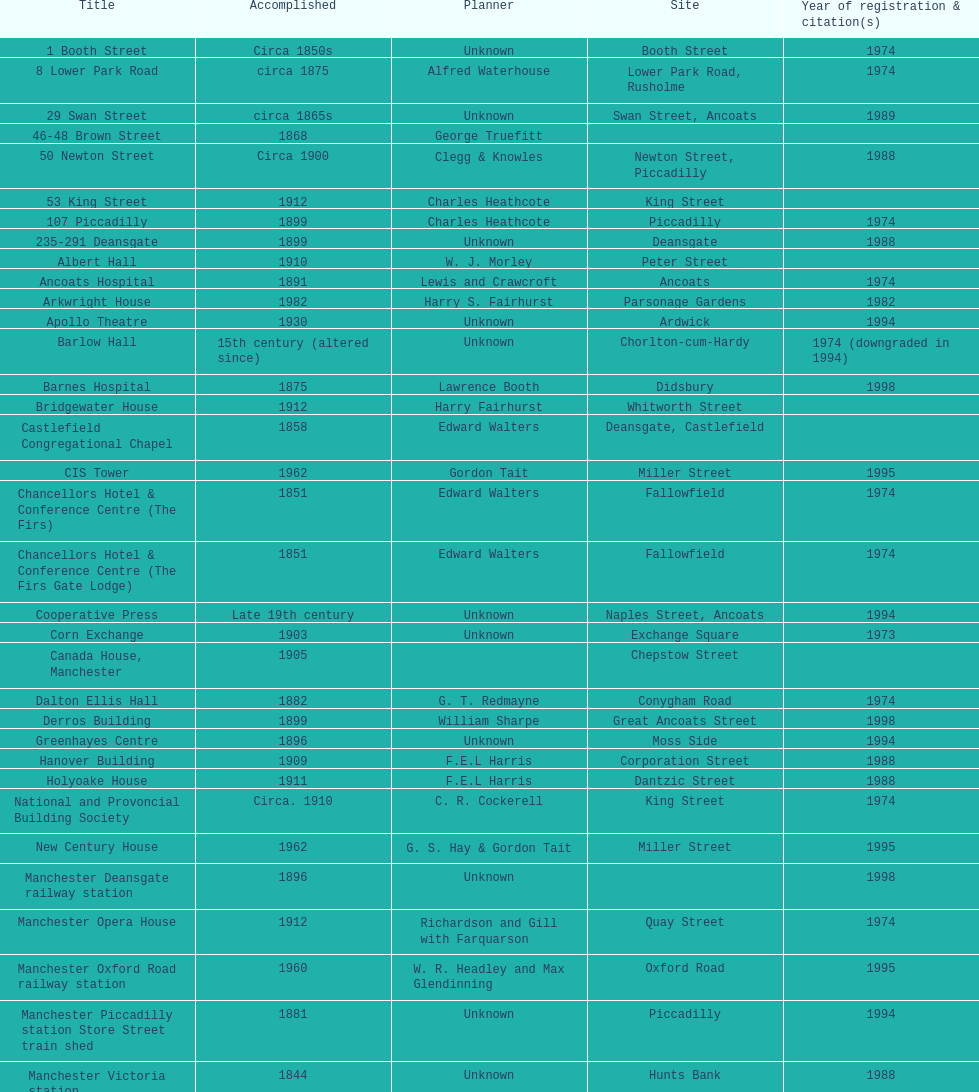Write the full table. {'header': ['Title', 'Accomplished', 'Planner', 'Site', 'Year of registration & citation(s)'], 'rows': [['1 Booth Street', 'Circa 1850s', 'Unknown', 'Booth Street', '1974'], ['8 Lower Park Road', 'circa 1875', 'Alfred Waterhouse', 'Lower Park Road, Rusholme', '1974'], ['29 Swan Street', 'circa 1865s', 'Unknown', 'Swan Street, Ancoats', '1989'], ['46-48 Brown Street', '1868', 'George Truefitt', '', ''], ['50 Newton Street', 'Circa 1900', 'Clegg & Knowles', 'Newton Street, Piccadilly', '1988'], ['53 King Street', '1912', 'Charles Heathcote', 'King Street', ''], ['107 Piccadilly', '1899', 'Charles Heathcote', 'Piccadilly', '1974'], ['235-291 Deansgate', '1899', 'Unknown', 'Deansgate', '1988'], ['Albert Hall', '1910', 'W. J. Morley', 'Peter Street', ''], ['Ancoats Hospital', '1891', 'Lewis and Crawcroft', 'Ancoats', '1974'], ['Arkwright House', '1982', 'Harry S. Fairhurst', 'Parsonage Gardens', '1982'], ['Apollo Theatre', '1930', 'Unknown', 'Ardwick', '1994'], ['Barlow Hall', '15th century (altered since)', 'Unknown', 'Chorlton-cum-Hardy', '1974 (downgraded in 1994)'], ['Barnes Hospital', '1875', 'Lawrence Booth', 'Didsbury', '1998'], ['Bridgewater House', '1912', 'Harry Fairhurst', 'Whitworth Street', ''], ['Castlefield Congregational Chapel', '1858', 'Edward Walters', 'Deansgate, Castlefield', ''], ['CIS Tower', '1962', 'Gordon Tait', 'Miller Street', '1995'], ['Chancellors Hotel & Conference Centre (The Firs)', '1851', 'Edward Walters', 'Fallowfield', '1974'], ['Chancellors Hotel & Conference Centre (The Firs Gate Lodge)', '1851', 'Edward Walters', 'Fallowfield', '1974'], ['Cooperative Press', 'Late 19th century', 'Unknown', 'Naples Street, Ancoats', '1994'], ['Corn Exchange', '1903', 'Unknown', 'Exchange Square', '1973'], ['Canada House, Manchester', '1905', '', 'Chepstow Street', ''], ['Dalton Ellis Hall', '1882', 'G. T. Redmayne', 'Conygham Road', '1974'], ['Derros Building', '1899', 'William Sharpe', 'Great Ancoats Street', '1998'], ['Greenhayes Centre', '1896', 'Unknown', 'Moss Side', '1994'], ['Hanover Building', '1909', 'F.E.L Harris', 'Corporation Street', '1988'], ['Holyoake House', '1911', 'F.E.L Harris', 'Dantzic Street', '1988'], ['National and Provoncial Building Society', 'Circa. 1910', 'C. R. Cockerell', 'King Street', '1974'], ['New Century House', '1962', 'G. S. Hay & Gordon Tait', 'Miller Street', '1995'], ['Manchester Deansgate railway station', '1896', 'Unknown', '', '1998'], ['Manchester Opera House', '1912', 'Richardson and Gill with Farquarson', 'Quay Street', '1974'], ['Manchester Oxford Road railway station', '1960', 'W. R. Headley and Max Glendinning', 'Oxford Road', '1995'], ['Manchester Piccadilly station Store Street train shed', '1881', 'Unknown', 'Piccadilly', '1994'], ['Manchester Victoria station', '1844', 'Unknown', 'Hunts Bank', '1988'], ['Palace Theatre', '1891', 'Alfred Derbyshire and F.Bennett Smith', 'Oxford Street', '1977'], ['The Ritz', '1927', 'Unknown', 'Whitworth Street', '1994'], ['Royal Exchange', '1921', 'Bradshaw, Gass & Hope', 'Cross Street', ''], ['Redfern Building', '1936', 'W. A. Johnson and J. W. Cooper', 'Dantzic Street', '1994'], ['Sackville Street Building', '1912', 'Spalding and Cross', 'Sackville Street', '1974'], ['St. James Buildings', '1912', 'Clegg, Fryer & Penman', '65-95 Oxford Street', '1988'], ["St Mary's Hospital", '1909', 'John Ely', 'Wilmslow Road', '1994'], ['Samuel Alexander Building', '1919', 'Percy Scott Worthington', 'Oxford Road', '2010'], ['Ship Canal House', '1927', 'Harry S. Fairhurst', 'King Street', '1982'], ['Smithfield Market Hall', '1857', 'Unknown', 'Swan Street, Ancoats', '1973'], ['Strangeways Gaol Gatehouse', '1868', 'Alfred Waterhouse', 'Sherborne Street', '1974'], ['Strangeways Prison ventilation and watch tower', '1868', 'Alfred Waterhouse', 'Sherborne Street', '1974'], ['Theatre Royal', '1845', 'Irwin and Chester', 'Peter Street', '1974'], ['Toast Rack', '1960', 'L. C. Howitt', 'Fallowfield', '1999'], ['The Old Wellington Inn', 'Mid-16th century', 'Unknown', 'Shambles Square', '1952'], ['Whitworth Park Mansions', 'Circa 1840s', 'Unknown', 'Whitworth Park', '1974']]} Which two buildings were listed before 1974? The Old Wellington Inn, Smithfield Market Hall. 